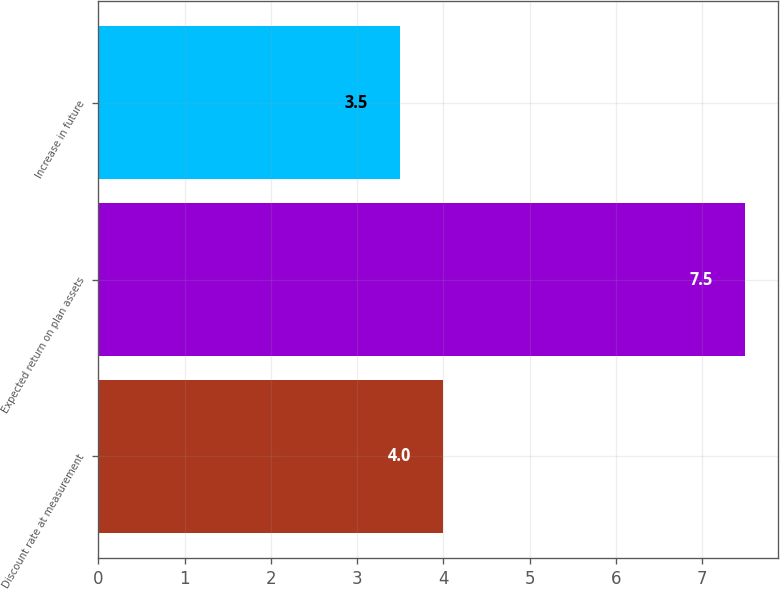<chart> <loc_0><loc_0><loc_500><loc_500><bar_chart><fcel>Discount rate at measurement<fcel>Expected return on plan assets<fcel>Increase in future<nl><fcel>4<fcel>7.5<fcel>3.5<nl></chart> 